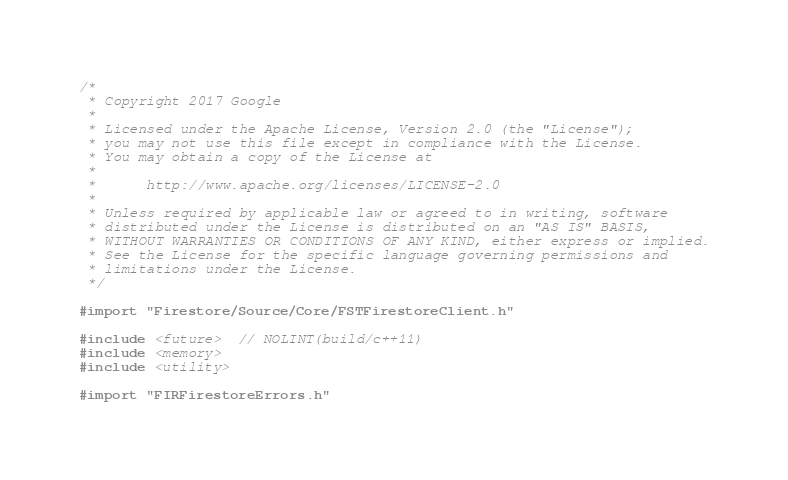<code> <loc_0><loc_0><loc_500><loc_500><_ObjectiveC_>/*
 * Copyright 2017 Google
 *
 * Licensed under the Apache License, Version 2.0 (the "License");
 * you may not use this file except in compliance with the License.
 * You may obtain a copy of the License at
 *
 *      http://www.apache.org/licenses/LICENSE-2.0
 *
 * Unless required by applicable law or agreed to in writing, software
 * distributed under the License is distributed on an "AS IS" BASIS,
 * WITHOUT WARRANTIES OR CONDITIONS OF ANY KIND, either express or implied.
 * See the License for the specific language governing permissions and
 * limitations under the License.
 */

#import "Firestore/Source/Core/FSTFirestoreClient.h"

#include <future>  // NOLINT(build/c++11)
#include <memory>
#include <utility>

#import "FIRFirestoreErrors.h"</code> 